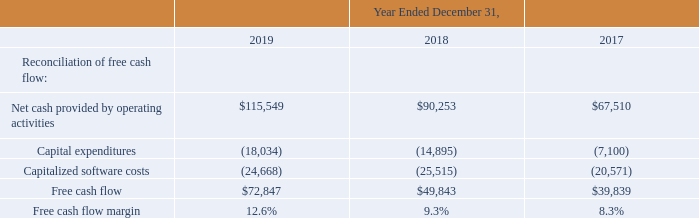Net Cash Provided By Operating Activities and Free Cash Flow
The following table presents a reconciliation of net cash provided by operating activities to free cash flow (in thousands, except for percentages):
Net cash provided by operating activities for the twelve months ended December 31, 2019 was $115.5 million as compared to $90.3 million during the same period in 2018. The increase was primarily due to improved profitability, improved collections, and other working capital changes in 2019 when compared to the same period in 2018.
Free cash flow for the twelve months ended December 31, 2019 was $72.8 million, resulting in a free cash flow margin of 12.6%, as compared to free cash flow of $49.8 million and a free cash flow margin of 9.3% for the same period in 2018. The increase was primarily due to both improved profitability and collections, and is partially offset by cash paid for interest on our convertible notes of $17.4 million in the twelve months ended December 31, 2019. Refer to the section titled “Liquidity and Capital Resources” for additional information on the convertible notes.
What was the reason behind the increase of net cash provided by operating activities between 2018 and 2019? The increase was primarily due to improved profitability, improved collections, and other working capital changes. What was the net cash provided by operating activities in 2017?
Answer scale should be: thousand. $67,510. What was the free cash flow in 2019?
Answer scale should be: thousand. $72,847. What was the average net cash provided by operating activities from 2017-2019?
Answer scale should be: thousand. ($115,549+$90,253+$67,510)/(2019-2017+1)
Answer: 91104. What was the change in free flow cash margin between 2017 and 2018?
Answer scale should be: percent. (9.3%-8.3%)
Answer: 1. What was the change in free cash flow between 2018 and 2019?
Answer scale should be: thousand. ($72,847-$49,843)
Answer: 23004. 